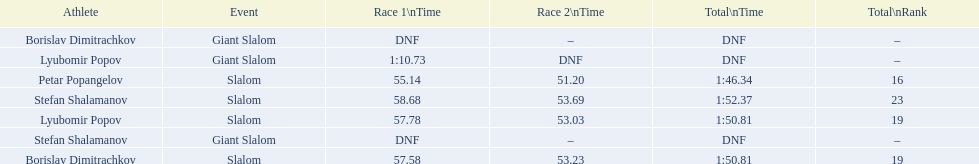Which athlete finished the first race but did not finish the second race? Lyubomir Popov. 